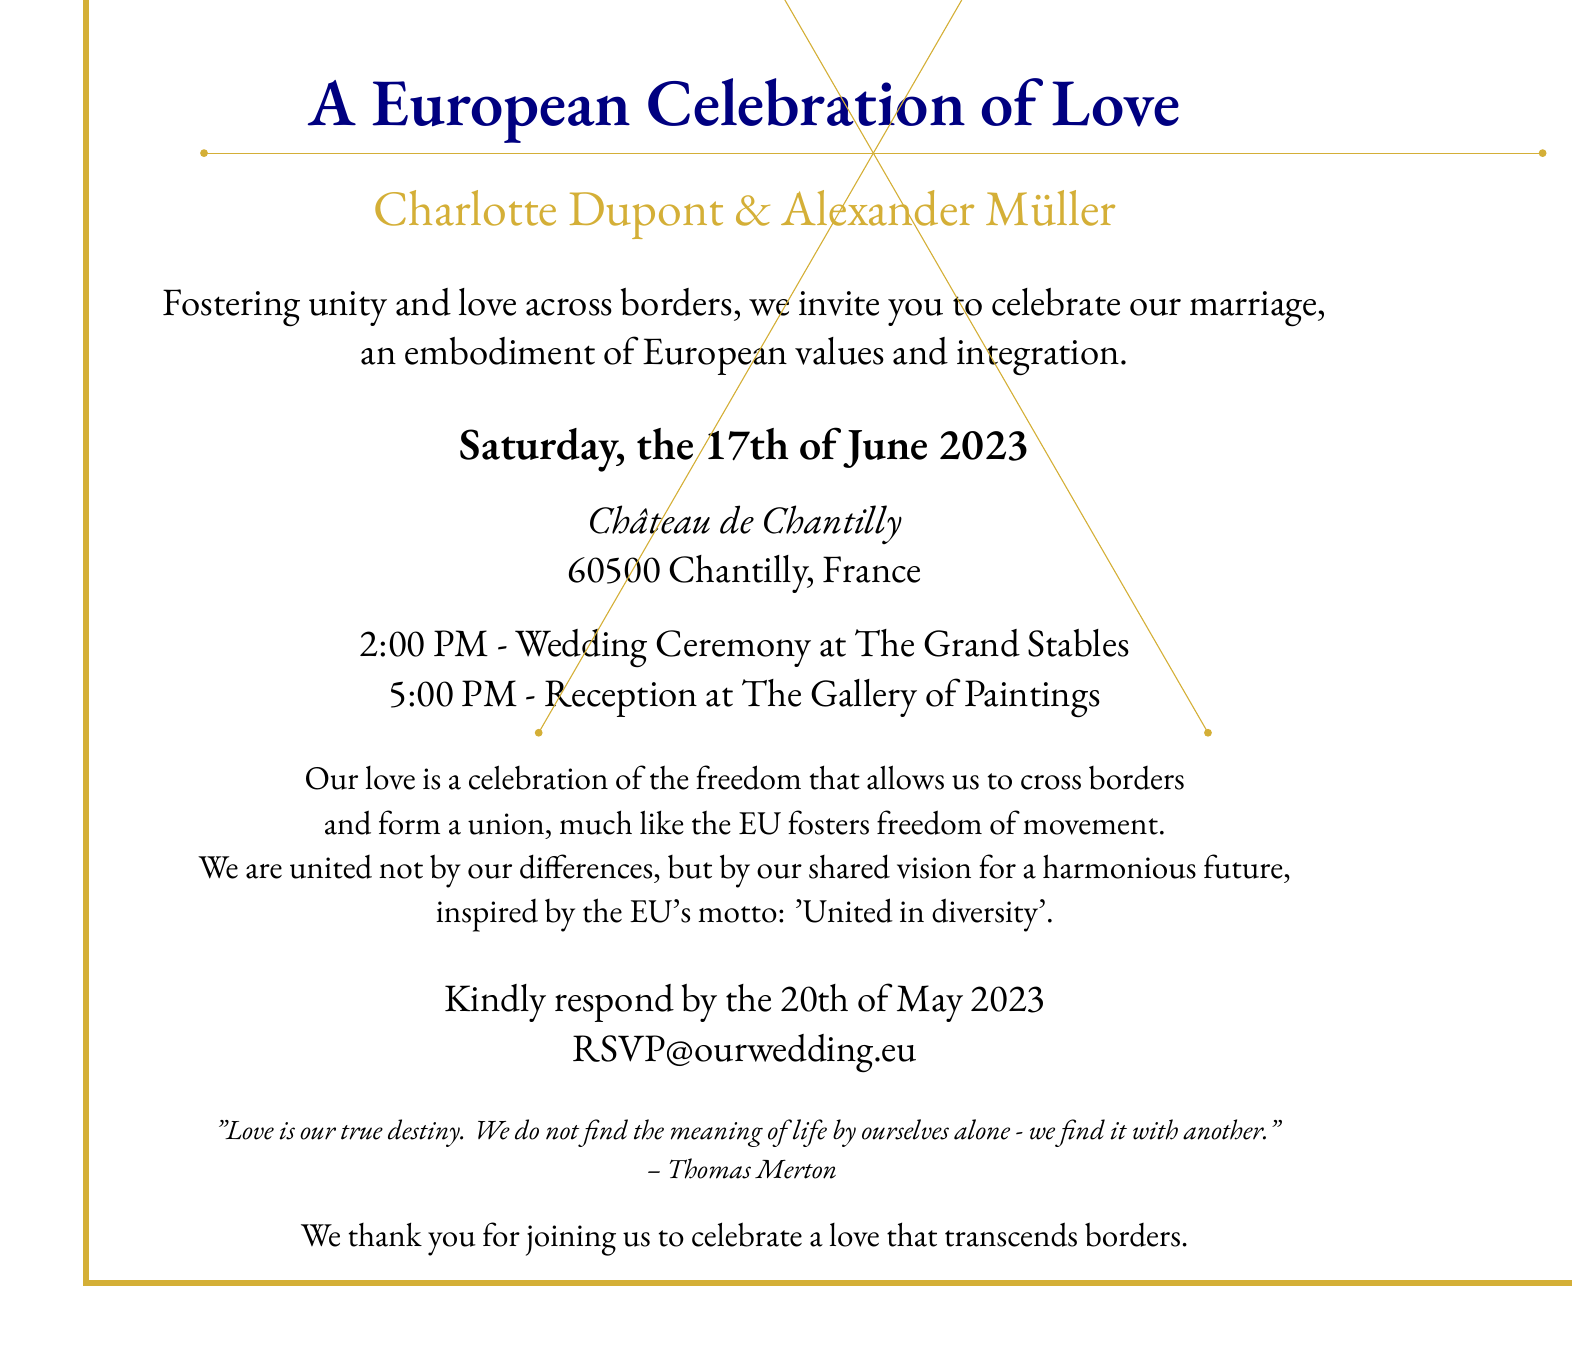What is the couple's names? The names of the couple getting married are prominently listed in the invitation.
Answer: Charlotte Dupont & Alexander Müller What date is the wedding ceremony? The specific date for the wedding ceremony is mentioned clearly in the document.
Answer: Saturday, the 17th of June 2023 Where is the wedding ceremony taking place? The location of the wedding ceremony is specified in the invitation.
Answer: Château de Chantilly What time does the wedding reception begin? The time for the wedding reception is provided in the schedule section.
Answer: 5:00 PM What is the deadline for RSVPs? The document specifies the date by which guests should respond to the invitation.
Answer: 20th of May 2023 What motto of the EU is referenced in the invitation? The invitation mentions the EU's motto, which reflects the couple's values.
Answer: United in diversity What is the theme of the wedding celebration? The invitation emphasizes the overarching theme that ties the event to European values.
Answer: A European Celebration of Love What visual motif is used in the design? The document includes specific design elements that symbolize the European context.
Answer: European flag motifs 